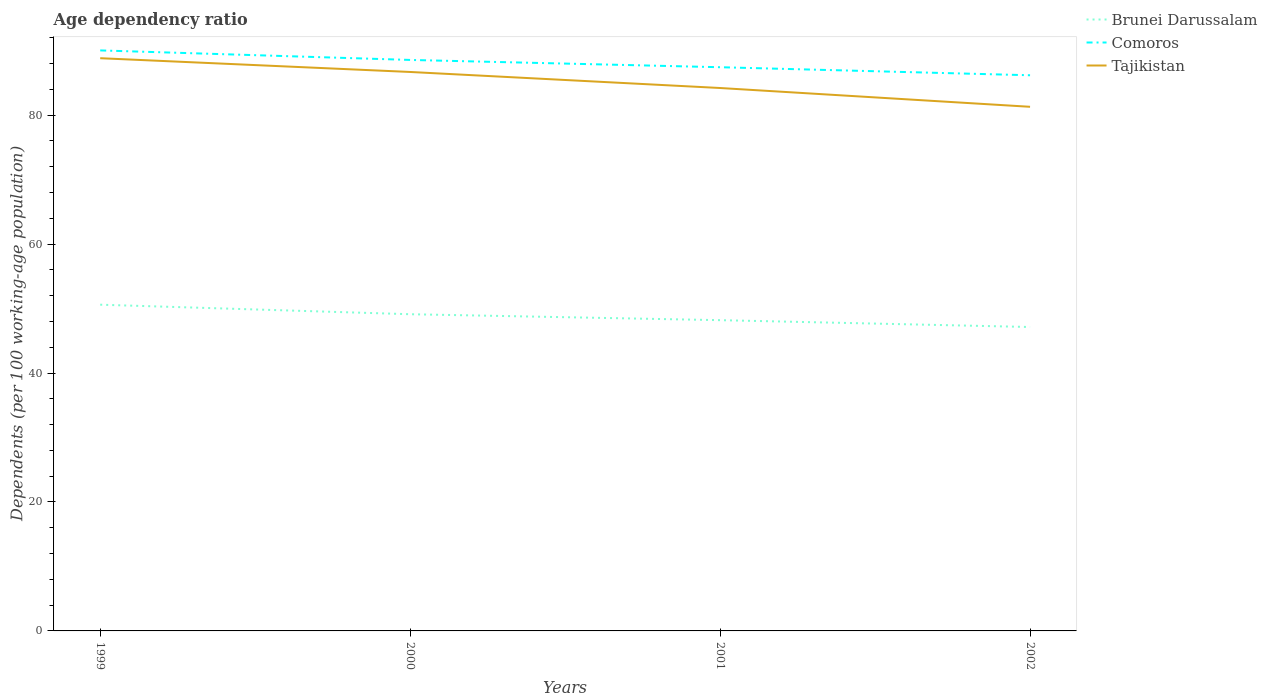How many different coloured lines are there?
Your answer should be very brief. 3. Does the line corresponding to Brunei Darussalam intersect with the line corresponding to Comoros?
Your response must be concise. No. Across all years, what is the maximum age dependency ratio in in Comoros?
Keep it short and to the point. 86.18. What is the total age dependency ratio in in Comoros in the graph?
Make the answer very short. 3.86. What is the difference between the highest and the second highest age dependency ratio in in Brunei Darussalam?
Give a very brief answer. 3.46. What is the difference between the highest and the lowest age dependency ratio in in Tajikistan?
Offer a terse response. 2. How many lines are there?
Offer a very short reply. 3. What is the difference between two consecutive major ticks on the Y-axis?
Keep it short and to the point. 20. Are the values on the major ticks of Y-axis written in scientific E-notation?
Your response must be concise. No. Does the graph contain any zero values?
Provide a succinct answer. No. Does the graph contain grids?
Provide a succinct answer. No. Where does the legend appear in the graph?
Offer a very short reply. Top right. How are the legend labels stacked?
Give a very brief answer. Vertical. What is the title of the graph?
Make the answer very short. Age dependency ratio. Does "East Asia (all income levels)" appear as one of the legend labels in the graph?
Ensure brevity in your answer.  No. What is the label or title of the Y-axis?
Keep it short and to the point. Dependents (per 100 working-age population). What is the Dependents (per 100 working-age population) of Brunei Darussalam in 1999?
Give a very brief answer. 50.6. What is the Dependents (per 100 working-age population) of Comoros in 1999?
Your answer should be compact. 90.03. What is the Dependents (per 100 working-age population) in Tajikistan in 1999?
Your answer should be very brief. 88.82. What is the Dependents (per 100 working-age population) in Brunei Darussalam in 2000?
Provide a succinct answer. 49.12. What is the Dependents (per 100 working-age population) in Comoros in 2000?
Make the answer very short. 88.56. What is the Dependents (per 100 working-age population) of Tajikistan in 2000?
Give a very brief answer. 86.69. What is the Dependents (per 100 working-age population) in Brunei Darussalam in 2001?
Your answer should be very brief. 48.2. What is the Dependents (per 100 working-age population) in Comoros in 2001?
Your answer should be compact. 87.43. What is the Dependents (per 100 working-age population) in Tajikistan in 2001?
Keep it short and to the point. 84.2. What is the Dependents (per 100 working-age population) in Brunei Darussalam in 2002?
Your response must be concise. 47.14. What is the Dependents (per 100 working-age population) of Comoros in 2002?
Provide a short and direct response. 86.18. What is the Dependents (per 100 working-age population) of Tajikistan in 2002?
Provide a succinct answer. 81.29. Across all years, what is the maximum Dependents (per 100 working-age population) in Brunei Darussalam?
Provide a succinct answer. 50.6. Across all years, what is the maximum Dependents (per 100 working-age population) of Comoros?
Provide a succinct answer. 90.03. Across all years, what is the maximum Dependents (per 100 working-age population) in Tajikistan?
Ensure brevity in your answer.  88.82. Across all years, what is the minimum Dependents (per 100 working-age population) in Brunei Darussalam?
Your response must be concise. 47.14. Across all years, what is the minimum Dependents (per 100 working-age population) of Comoros?
Offer a terse response. 86.18. Across all years, what is the minimum Dependents (per 100 working-age population) of Tajikistan?
Offer a very short reply. 81.29. What is the total Dependents (per 100 working-age population) of Brunei Darussalam in the graph?
Give a very brief answer. 195.05. What is the total Dependents (per 100 working-age population) of Comoros in the graph?
Keep it short and to the point. 352.2. What is the total Dependents (per 100 working-age population) in Tajikistan in the graph?
Provide a succinct answer. 341.01. What is the difference between the Dependents (per 100 working-age population) in Brunei Darussalam in 1999 and that in 2000?
Offer a very short reply. 1.48. What is the difference between the Dependents (per 100 working-age population) of Comoros in 1999 and that in 2000?
Give a very brief answer. 1.48. What is the difference between the Dependents (per 100 working-age population) of Tajikistan in 1999 and that in 2000?
Provide a succinct answer. 2.13. What is the difference between the Dependents (per 100 working-age population) in Brunei Darussalam in 1999 and that in 2001?
Make the answer very short. 2.4. What is the difference between the Dependents (per 100 working-age population) of Comoros in 1999 and that in 2001?
Give a very brief answer. 2.61. What is the difference between the Dependents (per 100 working-age population) in Tajikistan in 1999 and that in 2001?
Offer a terse response. 4.62. What is the difference between the Dependents (per 100 working-age population) of Brunei Darussalam in 1999 and that in 2002?
Ensure brevity in your answer.  3.46. What is the difference between the Dependents (per 100 working-age population) in Comoros in 1999 and that in 2002?
Provide a short and direct response. 3.86. What is the difference between the Dependents (per 100 working-age population) of Tajikistan in 1999 and that in 2002?
Give a very brief answer. 7.54. What is the difference between the Dependents (per 100 working-age population) of Brunei Darussalam in 2000 and that in 2001?
Your answer should be very brief. 0.92. What is the difference between the Dependents (per 100 working-age population) of Comoros in 2000 and that in 2001?
Make the answer very short. 1.13. What is the difference between the Dependents (per 100 working-age population) in Tajikistan in 2000 and that in 2001?
Your answer should be very brief. 2.49. What is the difference between the Dependents (per 100 working-age population) in Brunei Darussalam in 2000 and that in 2002?
Offer a very short reply. 1.98. What is the difference between the Dependents (per 100 working-age population) of Comoros in 2000 and that in 2002?
Provide a short and direct response. 2.38. What is the difference between the Dependents (per 100 working-age population) in Tajikistan in 2000 and that in 2002?
Ensure brevity in your answer.  5.4. What is the difference between the Dependents (per 100 working-age population) in Brunei Darussalam in 2001 and that in 2002?
Make the answer very short. 1.06. What is the difference between the Dependents (per 100 working-age population) in Comoros in 2001 and that in 2002?
Your response must be concise. 1.25. What is the difference between the Dependents (per 100 working-age population) in Tajikistan in 2001 and that in 2002?
Keep it short and to the point. 2.91. What is the difference between the Dependents (per 100 working-age population) in Brunei Darussalam in 1999 and the Dependents (per 100 working-age population) in Comoros in 2000?
Keep it short and to the point. -37.96. What is the difference between the Dependents (per 100 working-age population) in Brunei Darussalam in 1999 and the Dependents (per 100 working-age population) in Tajikistan in 2000?
Your answer should be very brief. -36.09. What is the difference between the Dependents (per 100 working-age population) of Comoros in 1999 and the Dependents (per 100 working-age population) of Tajikistan in 2000?
Make the answer very short. 3.34. What is the difference between the Dependents (per 100 working-age population) in Brunei Darussalam in 1999 and the Dependents (per 100 working-age population) in Comoros in 2001?
Give a very brief answer. -36.83. What is the difference between the Dependents (per 100 working-age population) of Brunei Darussalam in 1999 and the Dependents (per 100 working-age population) of Tajikistan in 2001?
Offer a terse response. -33.61. What is the difference between the Dependents (per 100 working-age population) of Comoros in 1999 and the Dependents (per 100 working-age population) of Tajikistan in 2001?
Keep it short and to the point. 5.83. What is the difference between the Dependents (per 100 working-age population) in Brunei Darussalam in 1999 and the Dependents (per 100 working-age population) in Comoros in 2002?
Provide a succinct answer. -35.58. What is the difference between the Dependents (per 100 working-age population) of Brunei Darussalam in 1999 and the Dependents (per 100 working-age population) of Tajikistan in 2002?
Keep it short and to the point. -30.69. What is the difference between the Dependents (per 100 working-age population) in Comoros in 1999 and the Dependents (per 100 working-age population) in Tajikistan in 2002?
Your response must be concise. 8.75. What is the difference between the Dependents (per 100 working-age population) in Brunei Darussalam in 2000 and the Dependents (per 100 working-age population) in Comoros in 2001?
Offer a terse response. -38.31. What is the difference between the Dependents (per 100 working-age population) in Brunei Darussalam in 2000 and the Dependents (per 100 working-age population) in Tajikistan in 2001?
Your answer should be compact. -35.09. What is the difference between the Dependents (per 100 working-age population) in Comoros in 2000 and the Dependents (per 100 working-age population) in Tajikistan in 2001?
Give a very brief answer. 4.35. What is the difference between the Dependents (per 100 working-age population) in Brunei Darussalam in 2000 and the Dependents (per 100 working-age population) in Comoros in 2002?
Your response must be concise. -37.06. What is the difference between the Dependents (per 100 working-age population) in Brunei Darussalam in 2000 and the Dependents (per 100 working-age population) in Tajikistan in 2002?
Make the answer very short. -32.17. What is the difference between the Dependents (per 100 working-age population) in Comoros in 2000 and the Dependents (per 100 working-age population) in Tajikistan in 2002?
Your answer should be compact. 7.27. What is the difference between the Dependents (per 100 working-age population) in Brunei Darussalam in 2001 and the Dependents (per 100 working-age population) in Comoros in 2002?
Provide a short and direct response. -37.98. What is the difference between the Dependents (per 100 working-age population) of Brunei Darussalam in 2001 and the Dependents (per 100 working-age population) of Tajikistan in 2002?
Make the answer very short. -33.09. What is the difference between the Dependents (per 100 working-age population) in Comoros in 2001 and the Dependents (per 100 working-age population) in Tajikistan in 2002?
Offer a very short reply. 6.14. What is the average Dependents (per 100 working-age population) in Brunei Darussalam per year?
Provide a short and direct response. 48.76. What is the average Dependents (per 100 working-age population) of Comoros per year?
Give a very brief answer. 88.05. What is the average Dependents (per 100 working-age population) in Tajikistan per year?
Give a very brief answer. 85.25. In the year 1999, what is the difference between the Dependents (per 100 working-age population) in Brunei Darussalam and Dependents (per 100 working-age population) in Comoros?
Your response must be concise. -39.44. In the year 1999, what is the difference between the Dependents (per 100 working-age population) in Brunei Darussalam and Dependents (per 100 working-age population) in Tajikistan?
Your answer should be compact. -38.23. In the year 1999, what is the difference between the Dependents (per 100 working-age population) of Comoros and Dependents (per 100 working-age population) of Tajikistan?
Your response must be concise. 1.21. In the year 2000, what is the difference between the Dependents (per 100 working-age population) of Brunei Darussalam and Dependents (per 100 working-age population) of Comoros?
Ensure brevity in your answer.  -39.44. In the year 2000, what is the difference between the Dependents (per 100 working-age population) of Brunei Darussalam and Dependents (per 100 working-age population) of Tajikistan?
Offer a terse response. -37.57. In the year 2000, what is the difference between the Dependents (per 100 working-age population) in Comoros and Dependents (per 100 working-age population) in Tajikistan?
Your response must be concise. 1.87. In the year 2001, what is the difference between the Dependents (per 100 working-age population) in Brunei Darussalam and Dependents (per 100 working-age population) in Comoros?
Ensure brevity in your answer.  -39.23. In the year 2001, what is the difference between the Dependents (per 100 working-age population) of Brunei Darussalam and Dependents (per 100 working-age population) of Tajikistan?
Give a very brief answer. -36.01. In the year 2001, what is the difference between the Dependents (per 100 working-age population) of Comoros and Dependents (per 100 working-age population) of Tajikistan?
Your answer should be compact. 3.22. In the year 2002, what is the difference between the Dependents (per 100 working-age population) in Brunei Darussalam and Dependents (per 100 working-age population) in Comoros?
Ensure brevity in your answer.  -39.04. In the year 2002, what is the difference between the Dependents (per 100 working-age population) in Brunei Darussalam and Dependents (per 100 working-age population) in Tajikistan?
Give a very brief answer. -34.15. In the year 2002, what is the difference between the Dependents (per 100 working-age population) of Comoros and Dependents (per 100 working-age population) of Tajikistan?
Your response must be concise. 4.89. What is the ratio of the Dependents (per 100 working-age population) in Brunei Darussalam in 1999 to that in 2000?
Keep it short and to the point. 1.03. What is the ratio of the Dependents (per 100 working-age population) of Comoros in 1999 to that in 2000?
Your answer should be very brief. 1.02. What is the ratio of the Dependents (per 100 working-age population) of Tajikistan in 1999 to that in 2000?
Provide a short and direct response. 1.02. What is the ratio of the Dependents (per 100 working-age population) in Brunei Darussalam in 1999 to that in 2001?
Ensure brevity in your answer.  1.05. What is the ratio of the Dependents (per 100 working-age population) of Comoros in 1999 to that in 2001?
Your response must be concise. 1.03. What is the ratio of the Dependents (per 100 working-age population) of Tajikistan in 1999 to that in 2001?
Provide a short and direct response. 1.05. What is the ratio of the Dependents (per 100 working-age population) in Brunei Darussalam in 1999 to that in 2002?
Provide a succinct answer. 1.07. What is the ratio of the Dependents (per 100 working-age population) of Comoros in 1999 to that in 2002?
Offer a terse response. 1.04. What is the ratio of the Dependents (per 100 working-age population) in Tajikistan in 1999 to that in 2002?
Your answer should be compact. 1.09. What is the ratio of the Dependents (per 100 working-age population) in Brunei Darussalam in 2000 to that in 2001?
Keep it short and to the point. 1.02. What is the ratio of the Dependents (per 100 working-age population) of Comoros in 2000 to that in 2001?
Your response must be concise. 1.01. What is the ratio of the Dependents (per 100 working-age population) of Tajikistan in 2000 to that in 2001?
Keep it short and to the point. 1.03. What is the ratio of the Dependents (per 100 working-age population) in Brunei Darussalam in 2000 to that in 2002?
Your answer should be compact. 1.04. What is the ratio of the Dependents (per 100 working-age population) in Comoros in 2000 to that in 2002?
Keep it short and to the point. 1.03. What is the ratio of the Dependents (per 100 working-age population) of Tajikistan in 2000 to that in 2002?
Offer a very short reply. 1.07. What is the ratio of the Dependents (per 100 working-age population) in Brunei Darussalam in 2001 to that in 2002?
Offer a very short reply. 1.02. What is the ratio of the Dependents (per 100 working-age population) of Comoros in 2001 to that in 2002?
Give a very brief answer. 1.01. What is the ratio of the Dependents (per 100 working-age population) of Tajikistan in 2001 to that in 2002?
Keep it short and to the point. 1.04. What is the difference between the highest and the second highest Dependents (per 100 working-age population) in Brunei Darussalam?
Offer a very short reply. 1.48. What is the difference between the highest and the second highest Dependents (per 100 working-age population) in Comoros?
Your response must be concise. 1.48. What is the difference between the highest and the second highest Dependents (per 100 working-age population) of Tajikistan?
Your answer should be compact. 2.13. What is the difference between the highest and the lowest Dependents (per 100 working-age population) of Brunei Darussalam?
Make the answer very short. 3.46. What is the difference between the highest and the lowest Dependents (per 100 working-age population) in Comoros?
Provide a succinct answer. 3.86. What is the difference between the highest and the lowest Dependents (per 100 working-age population) of Tajikistan?
Keep it short and to the point. 7.54. 